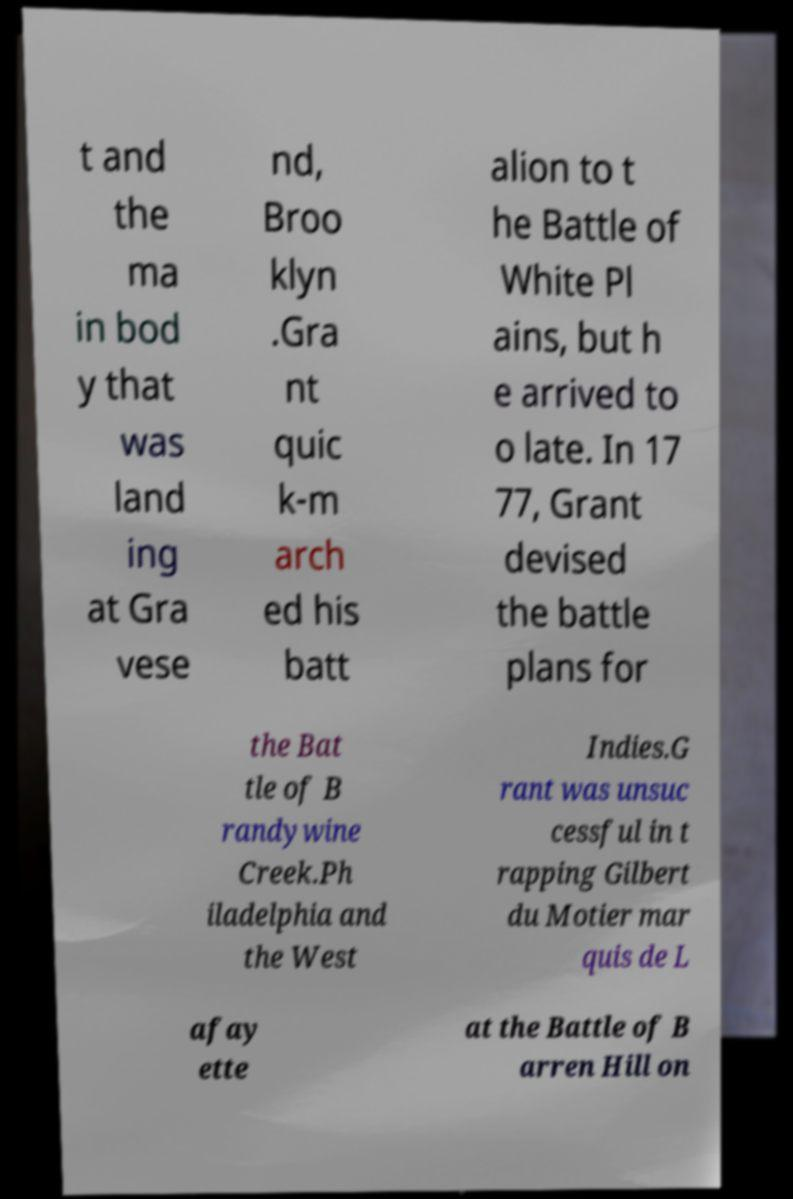There's text embedded in this image that I need extracted. Can you transcribe it verbatim? t and the ma in bod y that was land ing at Gra vese nd, Broo klyn .Gra nt quic k-m arch ed his batt alion to t he Battle of White Pl ains, but h e arrived to o late. In 17 77, Grant devised the battle plans for the Bat tle of B randywine Creek.Ph iladelphia and the West Indies.G rant was unsuc cessful in t rapping Gilbert du Motier mar quis de L afay ette at the Battle of B arren Hill on 